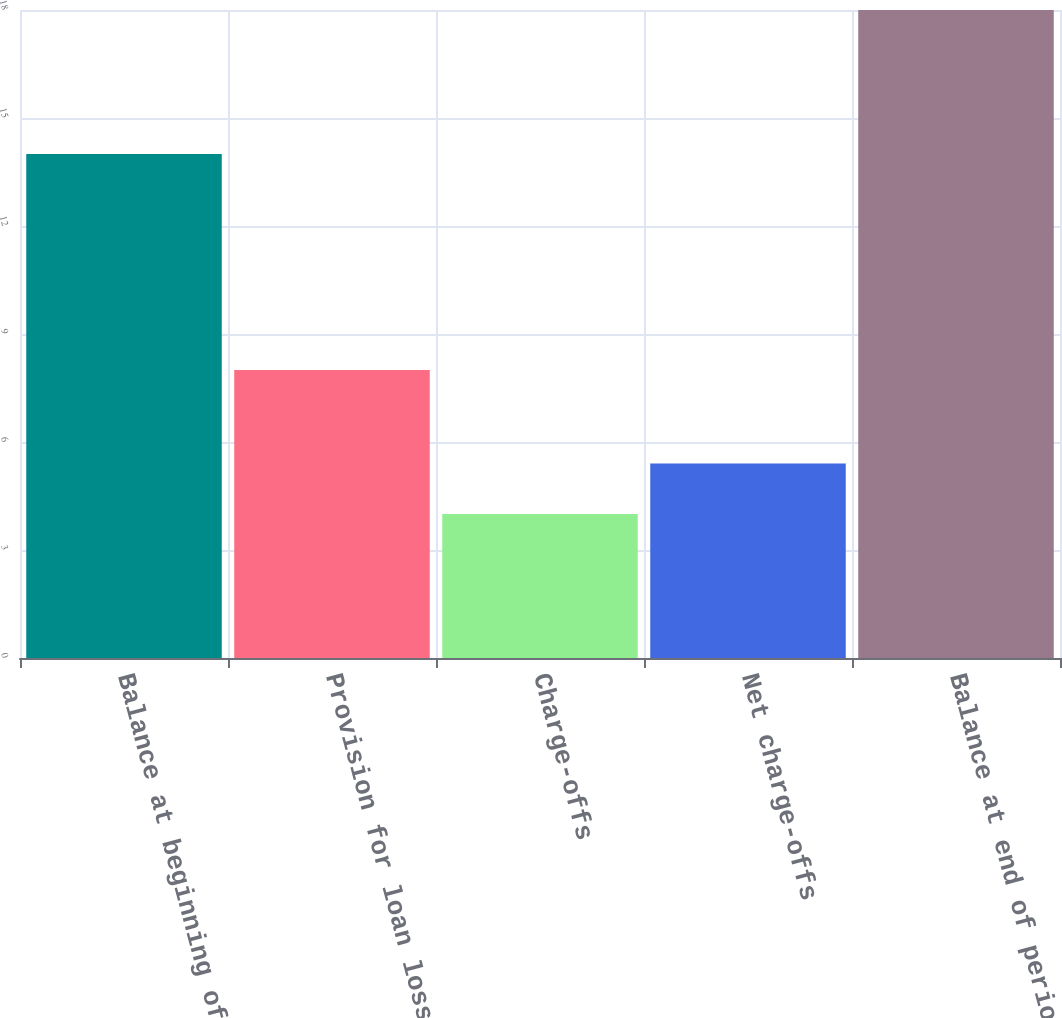Convert chart to OTSL. <chart><loc_0><loc_0><loc_500><loc_500><bar_chart><fcel>Balance at beginning of period<fcel>Provision for loan losses<fcel>Charge-offs<fcel>Net charge-offs<fcel>Balance at end of period<nl><fcel>14<fcel>8<fcel>4<fcel>5.4<fcel>18<nl></chart> 